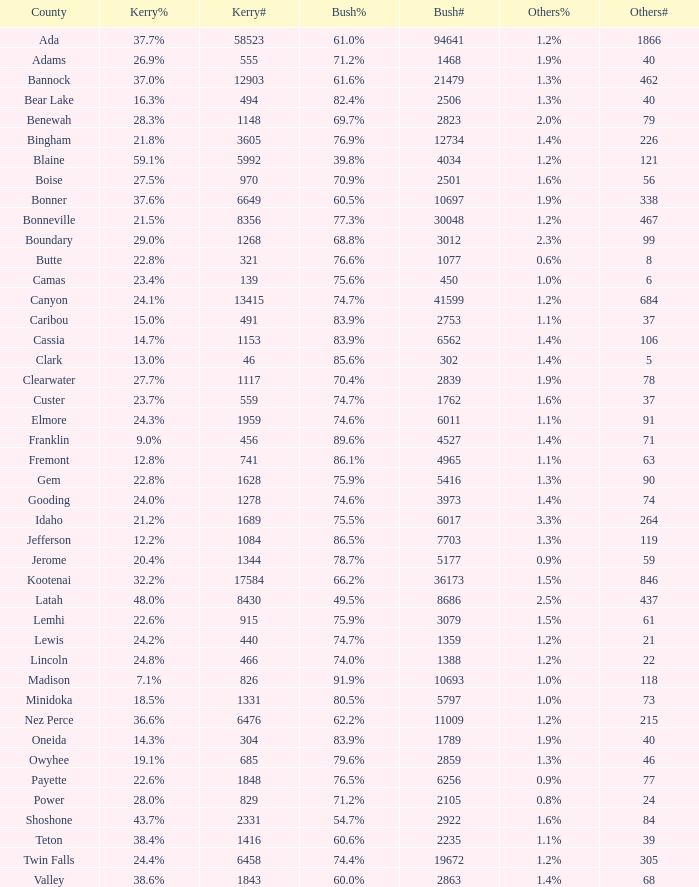What percentage of the votes were for others in the county where 462 people voted that way? 1.3%. 